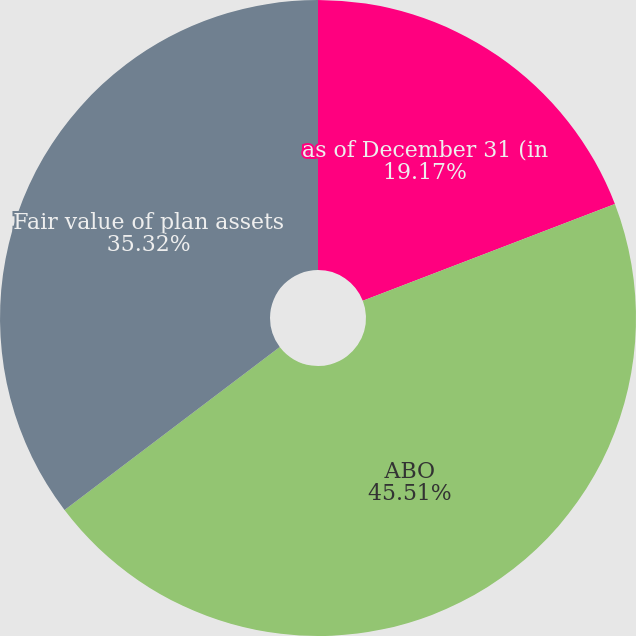Convert chart to OTSL. <chart><loc_0><loc_0><loc_500><loc_500><pie_chart><fcel>as of December 31 (in<fcel>ABO<fcel>Fair value of plan assets<nl><fcel>19.17%<fcel>45.51%<fcel>35.32%<nl></chart> 